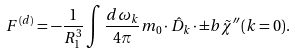Convert formula to latex. <formula><loc_0><loc_0><loc_500><loc_500>F ^ { ( d ) } = - \frac { 1 } { R _ { 1 } ^ { 3 } } \int \frac { d \omega _ { k } } { 4 \pi } m _ { 0 } \cdot \hat { D } _ { k } \cdot \pm b { \tilde { \chi } } ^ { \prime \prime } ( k = 0 ) .</formula> 